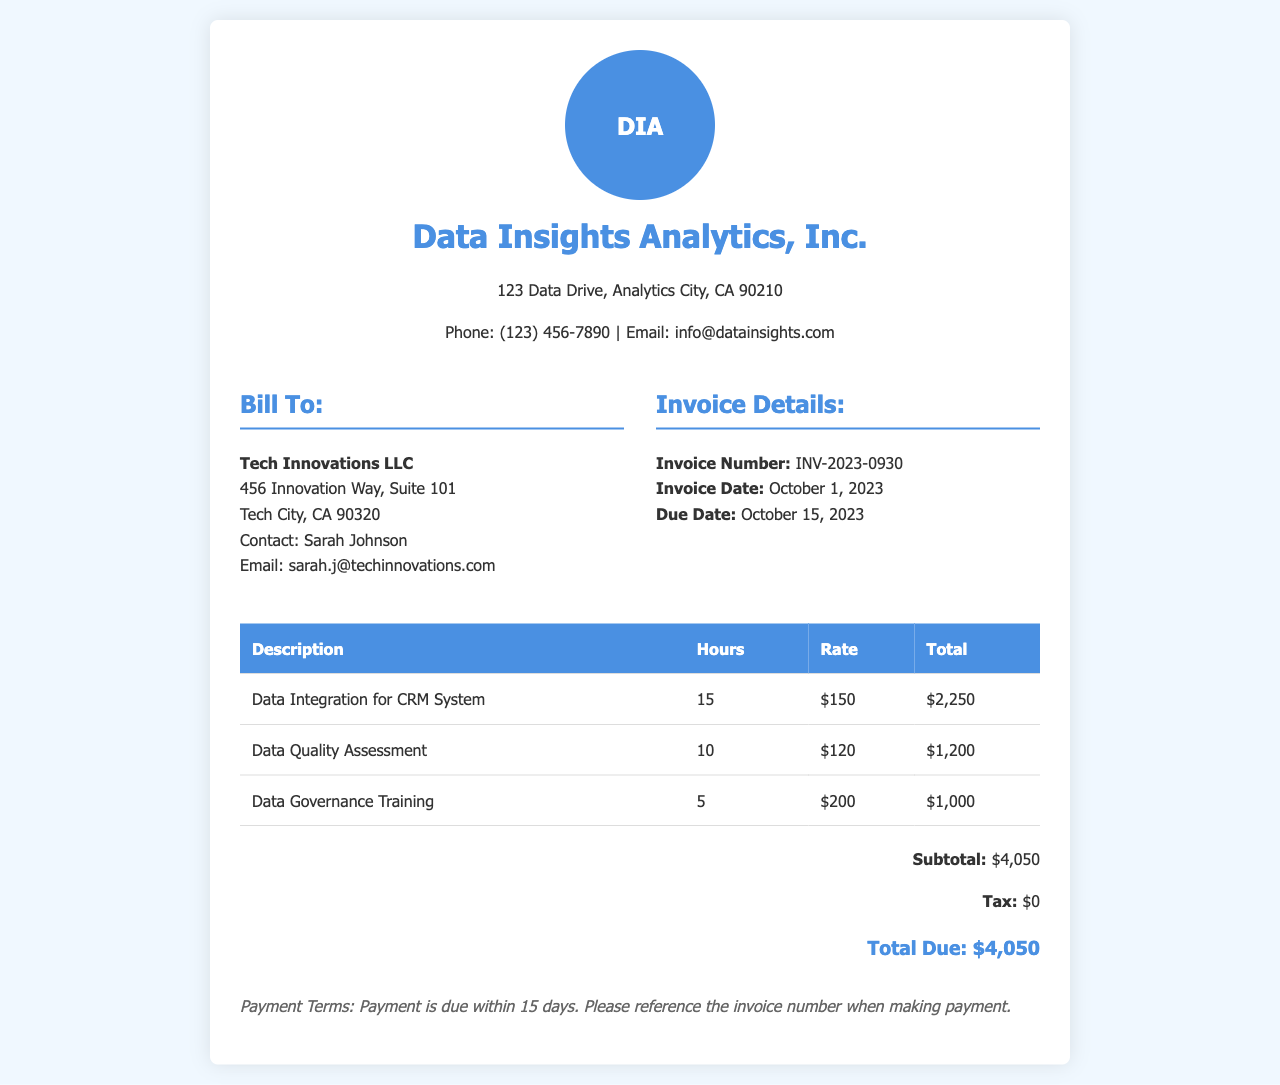What is the total due? The total due is the final amount after all calculations, which is listed at the bottom of the document.
Answer: $4,050 What is the invoice number? The invoice number is a unique identifier for this receipt, found under Invoice Details.
Answer: INV-2023-0930 Who is the contact person for Tech Innovations LLC? The contact person is mentioned in the billing section of the document.
Answer: Sarah Johnson How many hours were worked for Data Integration for CRM System? The number of hours worked is displayed in the table for the specific service rendered.
Answer: 15 What is the rate for Data Quality Assessment? The rate per hour for the service is shown in the table next to its description.
Answer: $120 What is the subtotal before tax? The subtotal is the sum of all charges before tax is applied.
Answer: $4,050 What is the due date for the invoice? The due date is specified in the invoice details section of the document.
Answer: October 15, 2023 How many hours were allocated to Data Governance Training? The hours allocated are listed in the hours column of the table for that specific service.
Answer: 5 What are the payment terms? The terms state how long the client has to make payment and any reference needed.
Answer: Payment is due within 15 days 